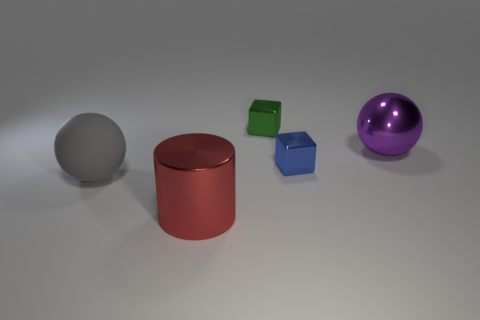What number of metal blocks are the same size as the red thing?
Make the answer very short. 0. What is the material of the thing to the left of the red thing?
Your response must be concise. Rubber. What number of big red things have the same shape as the blue thing?
Your answer should be compact. 0. The tiny blue thing that is made of the same material as the big purple object is what shape?
Your answer should be compact. Cube. There is a large object to the left of the red shiny object that is in front of the sphere on the left side of the red thing; what is its shape?
Make the answer very short. Sphere. Is the number of large red metallic cylinders greater than the number of purple matte cylinders?
Keep it short and to the point. Yes. What is the material of the big gray object that is the same shape as the purple thing?
Your response must be concise. Rubber. Do the large purple object and the green cube have the same material?
Provide a short and direct response. Yes. Are there more big purple spheres in front of the large gray thing than purple things?
Keep it short and to the point. No. What material is the large sphere on the left side of the tiny shiny block that is behind the big metallic object to the right of the tiny green metallic block made of?
Give a very brief answer. Rubber. 